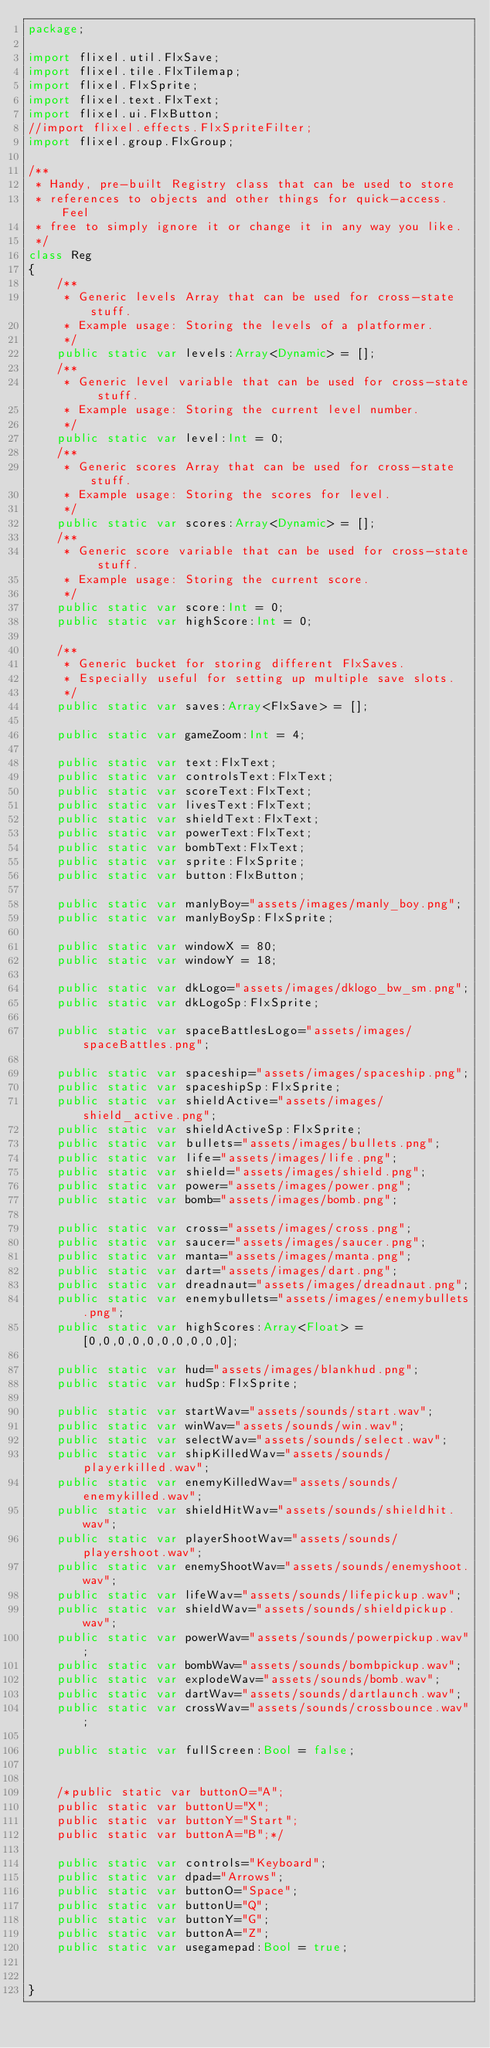Convert code to text. <code><loc_0><loc_0><loc_500><loc_500><_Haxe_>package;

import flixel.util.FlxSave;
import flixel.tile.FlxTilemap;
import flixel.FlxSprite;
import flixel.text.FlxText;
import flixel.ui.FlxButton;
//import flixel.effects.FlxSpriteFilter;
import flixel.group.FlxGroup;

/**
 * Handy, pre-built Registry class that can be used to store 
 * references to objects and other things for quick-access. Feel
 * free to simply ignore it or change it in any way you like.
 */
class Reg
{
	/**
	 * Generic levels Array that can be used for cross-state stuff.
	 * Example usage: Storing the levels of a platformer.
	 */
	public static var levels:Array<Dynamic> = [];
	/**
	 * Generic level variable that can be used for cross-state stuff.
	 * Example usage: Storing the current level number.
	 */
	public static var level:Int = 0;
	/**
	 * Generic scores Array that can be used for cross-state stuff.
	 * Example usage: Storing the scores for level.
	 */
	public static var scores:Array<Dynamic> = [];
	/**
	 * Generic score variable that can be used for cross-state stuff.
	 * Example usage: Storing the current score.
	 */
	public static var score:Int = 0;
	public static var highScore:Int = 0;
	
	/**
	 * Generic bucket for storing different FlxSaves.
	 * Especially useful for setting up multiple save slots.
	 */
	public static var saves:Array<FlxSave> = [];
	
	public static var gameZoom:Int = 4;
	
	public static var text:FlxText;
	public static var controlsText:FlxText;
	public static var scoreText:FlxText;
	public static var livesText:FlxText;
	public static var shieldText:FlxText;
	public static var powerText:FlxText;
	public static var bombText:FlxText;
	public static var sprite:FlxSprite;
	public static var button:FlxButton;
	
	public static var manlyBoy="assets/images/manly_boy.png";
	public static var manlyBoySp:FlxSprite;
	
	public static var windowX = 80;
	public static var windowY = 18;
	
	public static var dkLogo="assets/images/dklogo_bw_sm.png";
	public static var dkLogoSp:FlxSprite;
	
	public static var spaceBattlesLogo="assets/images/spaceBattles.png";
	
	public static var spaceship="assets/images/spaceship.png";
	public static var spaceshipSp:FlxSprite;
	public static var shieldActive="assets/images/shield_active.png";
	public static var shieldActiveSp:FlxSprite;
	public static var bullets="assets/images/bullets.png";
	public static var life="assets/images/life.png";
	public static var shield="assets/images/shield.png";
	public static var power="assets/images/power.png";
	public static var bomb="assets/images/bomb.png";
	
	public static var cross="assets/images/cross.png";
	public static var saucer="assets/images/saucer.png";
	public static var manta="assets/images/manta.png";
	public static var dart="assets/images/dart.png";
	public static var dreadnaut="assets/images/dreadnaut.png";
	public static var enemybullets="assets/images/enemybullets.png";
	public static var highScores:Array<Float> = [0,0,0,0,0,0,0,0,0,0];
	
	public static var hud="assets/images/blankhud.png";
	public static var hudSp:FlxSprite;
	
	public static var startWav="assets/sounds/start.wav";
	public static var winWav="assets/sounds/win.wav";
	public static var selectWav="assets/sounds/select.wav";
	public static var shipKilledWav="assets/sounds/playerkilled.wav";
	public static var enemyKilledWav="assets/sounds/enemykilled.wav";
	public static var shieldHitWav="assets/sounds/shieldhit.wav";
	public static var playerShootWav="assets/sounds/playershoot.wav";
	public static var enemyShootWav="assets/sounds/enemyshoot.wav";
	public static var lifeWav="assets/sounds/lifepickup.wav";
	public static var shieldWav="assets/sounds/shieldpickup.wav";
	public static var powerWav="assets/sounds/powerpickup.wav";
	public static var bombWav="assets/sounds/bombpickup.wav";
	public static var explodeWav="assets/sounds/bomb.wav";
	public static var dartWav="assets/sounds/dartlaunch.wav";
	public static var crossWav="assets/sounds/crossbounce.wav";
	
	public static var fullScreen:Bool = false;
	
	
	/*public static var buttonO="A";
	public static var buttonU="X";
	public static var buttonY="Start";
	public static var buttonA="B";*/
	
	public static var controls="Keyboard";
	public static var dpad="Arrows";
	public static var buttonO="Space";
	public static var buttonU="Q";
	public static var buttonY="G";
	public static var buttonA="Z";
	public static var usegamepad:Bool = true;
		
	
}
</code> 